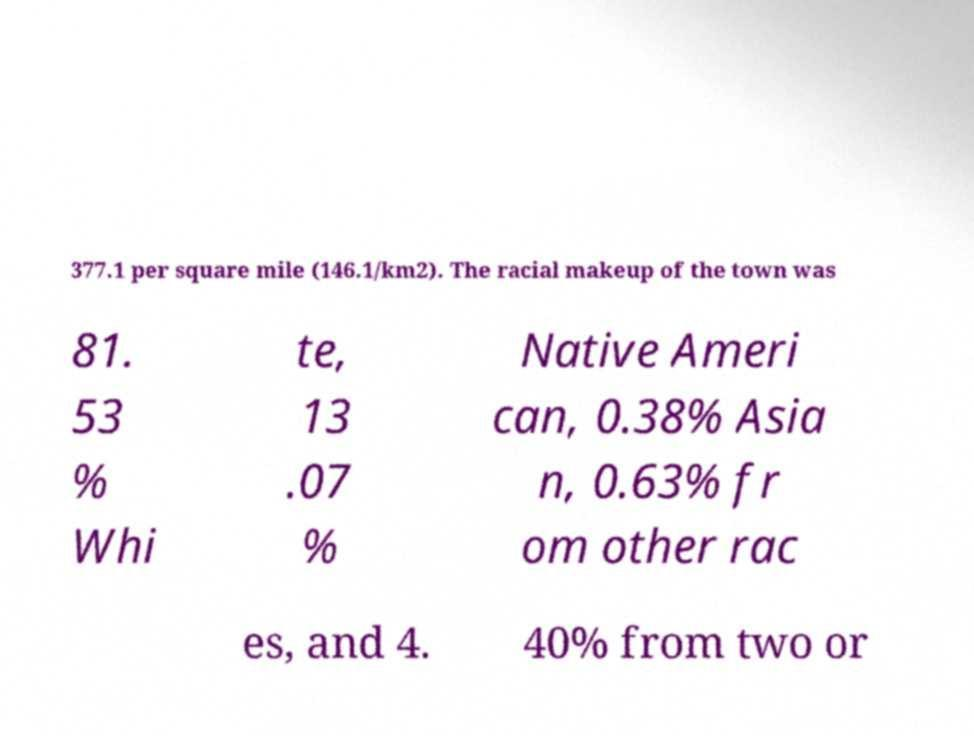Please read and relay the text visible in this image. What does it say? 377.1 per square mile (146.1/km2). The racial makeup of the town was 81. 53 % Whi te, 13 .07 % Native Ameri can, 0.38% Asia n, 0.63% fr om other rac es, and 4. 40% from two or 